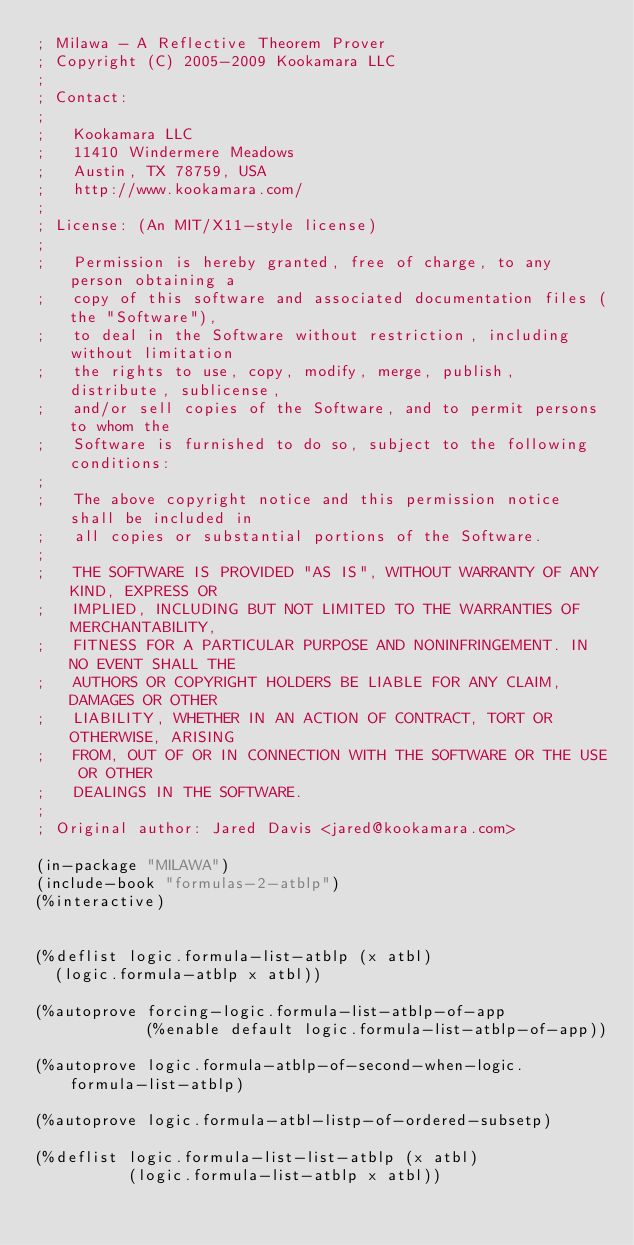Convert code to text. <code><loc_0><loc_0><loc_500><loc_500><_Lisp_>; Milawa - A Reflective Theorem Prover
; Copyright (C) 2005-2009 Kookamara LLC
;
; Contact:
;
;   Kookamara LLC
;   11410 Windermere Meadows
;   Austin, TX 78759, USA
;   http://www.kookamara.com/
;
; License: (An MIT/X11-style license)
;
;   Permission is hereby granted, free of charge, to any person obtaining a
;   copy of this software and associated documentation files (the "Software"),
;   to deal in the Software without restriction, including without limitation
;   the rights to use, copy, modify, merge, publish, distribute, sublicense,
;   and/or sell copies of the Software, and to permit persons to whom the
;   Software is furnished to do so, subject to the following conditions:
;
;   The above copyright notice and this permission notice shall be included in
;   all copies or substantial portions of the Software.
;
;   THE SOFTWARE IS PROVIDED "AS IS", WITHOUT WARRANTY OF ANY KIND, EXPRESS OR
;   IMPLIED, INCLUDING BUT NOT LIMITED TO THE WARRANTIES OF MERCHANTABILITY,
;   FITNESS FOR A PARTICULAR PURPOSE AND NONINFRINGEMENT. IN NO EVENT SHALL THE
;   AUTHORS OR COPYRIGHT HOLDERS BE LIABLE FOR ANY CLAIM, DAMAGES OR OTHER
;   LIABILITY, WHETHER IN AN ACTION OF CONTRACT, TORT OR OTHERWISE, ARISING
;   FROM, OUT OF OR IN CONNECTION WITH THE SOFTWARE OR THE USE OR OTHER
;   DEALINGS IN THE SOFTWARE.
;
; Original author: Jared Davis <jared@kookamara.com>

(in-package "MILAWA")
(include-book "formulas-2-atblp")
(%interactive)


(%deflist logic.formula-list-atblp (x atbl)
  (logic.formula-atblp x atbl))

(%autoprove forcing-logic.formula-list-atblp-of-app
            (%enable default logic.formula-list-atblp-of-app))

(%autoprove logic.formula-atblp-of-second-when-logic.formula-list-atblp)

(%autoprove logic.formula-atbl-listp-of-ordered-subsetp)

(%deflist logic.formula-list-list-atblp (x atbl)
          (logic.formula-list-atblp x atbl))

</code> 